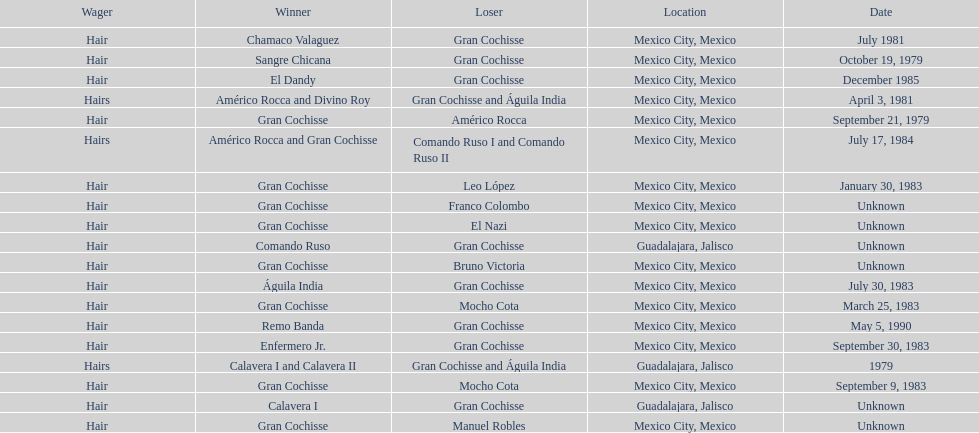When did bruno victoria lose his first game? Unknown. 